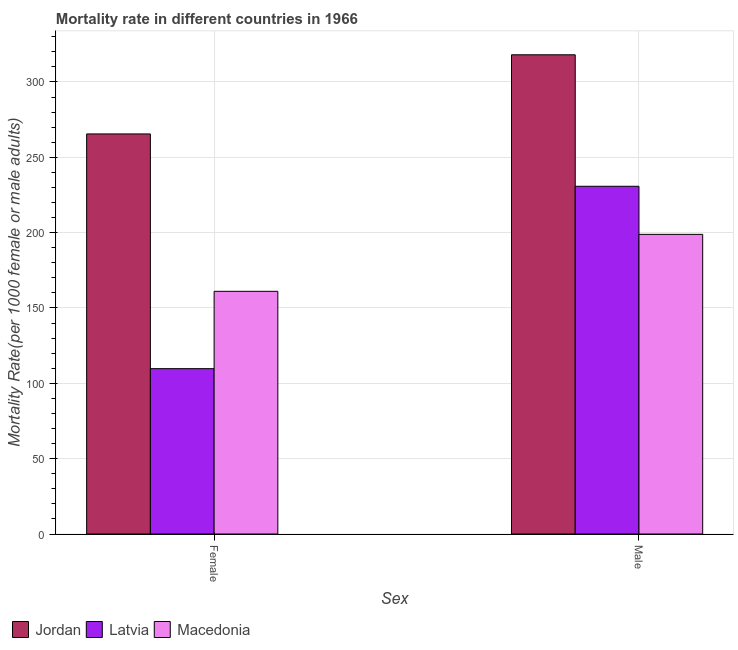Are the number of bars per tick equal to the number of legend labels?
Make the answer very short. Yes. Are the number of bars on each tick of the X-axis equal?
Keep it short and to the point. Yes. What is the label of the 1st group of bars from the left?
Offer a terse response. Female. What is the female mortality rate in Macedonia?
Offer a terse response. 161.06. Across all countries, what is the maximum female mortality rate?
Your answer should be compact. 265.5. Across all countries, what is the minimum female mortality rate?
Offer a very short reply. 109.72. In which country was the male mortality rate maximum?
Your answer should be very brief. Jordan. In which country was the male mortality rate minimum?
Give a very brief answer. Macedonia. What is the total female mortality rate in the graph?
Your response must be concise. 536.29. What is the difference between the male mortality rate in Macedonia and that in Latvia?
Make the answer very short. -31.91. What is the difference between the female mortality rate in Jordan and the male mortality rate in Latvia?
Offer a terse response. 34.74. What is the average male mortality rate per country?
Ensure brevity in your answer.  249.21. What is the difference between the female mortality rate and male mortality rate in Jordan?
Provide a short and direct response. -52.52. What is the ratio of the female mortality rate in Latvia to that in Jordan?
Ensure brevity in your answer.  0.41. What does the 1st bar from the left in Male represents?
Give a very brief answer. Jordan. What does the 2nd bar from the right in Female represents?
Ensure brevity in your answer.  Latvia. Are all the bars in the graph horizontal?
Ensure brevity in your answer.  No. What is the difference between two consecutive major ticks on the Y-axis?
Your response must be concise. 50. Are the values on the major ticks of Y-axis written in scientific E-notation?
Offer a very short reply. No. Where does the legend appear in the graph?
Give a very brief answer. Bottom left. What is the title of the graph?
Give a very brief answer. Mortality rate in different countries in 1966. What is the label or title of the X-axis?
Offer a very short reply. Sex. What is the label or title of the Y-axis?
Offer a very short reply. Mortality Rate(per 1000 female or male adults). What is the Mortality Rate(per 1000 female or male adults) of Jordan in Female?
Provide a succinct answer. 265.5. What is the Mortality Rate(per 1000 female or male adults) in Latvia in Female?
Your answer should be very brief. 109.72. What is the Mortality Rate(per 1000 female or male adults) in Macedonia in Female?
Your answer should be very brief. 161.06. What is the Mortality Rate(per 1000 female or male adults) in Jordan in Male?
Provide a succinct answer. 318.03. What is the Mortality Rate(per 1000 female or male adults) of Latvia in Male?
Give a very brief answer. 230.76. What is the Mortality Rate(per 1000 female or male adults) in Macedonia in Male?
Make the answer very short. 198.85. Across all Sex, what is the maximum Mortality Rate(per 1000 female or male adults) in Jordan?
Make the answer very short. 318.03. Across all Sex, what is the maximum Mortality Rate(per 1000 female or male adults) of Latvia?
Offer a very short reply. 230.76. Across all Sex, what is the maximum Mortality Rate(per 1000 female or male adults) of Macedonia?
Offer a very short reply. 198.85. Across all Sex, what is the minimum Mortality Rate(per 1000 female or male adults) in Jordan?
Keep it short and to the point. 265.5. Across all Sex, what is the minimum Mortality Rate(per 1000 female or male adults) of Latvia?
Offer a terse response. 109.72. Across all Sex, what is the minimum Mortality Rate(per 1000 female or male adults) of Macedonia?
Your answer should be very brief. 161.06. What is the total Mortality Rate(per 1000 female or male adults) of Jordan in the graph?
Your response must be concise. 583.53. What is the total Mortality Rate(per 1000 female or male adults) in Latvia in the graph?
Your answer should be compact. 340.49. What is the total Mortality Rate(per 1000 female or male adults) in Macedonia in the graph?
Offer a terse response. 359.91. What is the difference between the Mortality Rate(per 1000 female or male adults) in Jordan in Female and that in Male?
Give a very brief answer. -52.52. What is the difference between the Mortality Rate(per 1000 female or male adults) of Latvia in Female and that in Male?
Give a very brief answer. -121.04. What is the difference between the Mortality Rate(per 1000 female or male adults) in Macedonia in Female and that in Male?
Make the answer very short. -37.8. What is the difference between the Mortality Rate(per 1000 female or male adults) in Jordan in Female and the Mortality Rate(per 1000 female or male adults) in Latvia in Male?
Your answer should be compact. 34.74. What is the difference between the Mortality Rate(per 1000 female or male adults) of Jordan in Female and the Mortality Rate(per 1000 female or male adults) of Macedonia in Male?
Your response must be concise. 66.65. What is the difference between the Mortality Rate(per 1000 female or male adults) of Latvia in Female and the Mortality Rate(per 1000 female or male adults) of Macedonia in Male?
Ensure brevity in your answer.  -89.13. What is the average Mortality Rate(per 1000 female or male adults) of Jordan per Sex?
Keep it short and to the point. 291.77. What is the average Mortality Rate(per 1000 female or male adults) of Latvia per Sex?
Your answer should be compact. 170.24. What is the average Mortality Rate(per 1000 female or male adults) in Macedonia per Sex?
Provide a short and direct response. 179.96. What is the difference between the Mortality Rate(per 1000 female or male adults) in Jordan and Mortality Rate(per 1000 female or male adults) in Latvia in Female?
Make the answer very short. 155.78. What is the difference between the Mortality Rate(per 1000 female or male adults) in Jordan and Mortality Rate(per 1000 female or male adults) in Macedonia in Female?
Ensure brevity in your answer.  104.45. What is the difference between the Mortality Rate(per 1000 female or male adults) in Latvia and Mortality Rate(per 1000 female or male adults) in Macedonia in Female?
Your answer should be compact. -51.33. What is the difference between the Mortality Rate(per 1000 female or male adults) in Jordan and Mortality Rate(per 1000 female or male adults) in Latvia in Male?
Offer a terse response. 87.26. What is the difference between the Mortality Rate(per 1000 female or male adults) in Jordan and Mortality Rate(per 1000 female or male adults) in Macedonia in Male?
Your response must be concise. 119.17. What is the difference between the Mortality Rate(per 1000 female or male adults) of Latvia and Mortality Rate(per 1000 female or male adults) of Macedonia in Male?
Ensure brevity in your answer.  31.91. What is the ratio of the Mortality Rate(per 1000 female or male adults) in Jordan in Female to that in Male?
Offer a very short reply. 0.83. What is the ratio of the Mortality Rate(per 1000 female or male adults) in Latvia in Female to that in Male?
Offer a terse response. 0.48. What is the ratio of the Mortality Rate(per 1000 female or male adults) in Macedonia in Female to that in Male?
Offer a very short reply. 0.81. What is the difference between the highest and the second highest Mortality Rate(per 1000 female or male adults) of Jordan?
Keep it short and to the point. 52.52. What is the difference between the highest and the second highest Mortality Rate(per 1000 female or male adults) in Latvia?
Keep it short and to the point. 121.04. What is the difference between the highest and the second highest Mortality Rate(per 1000 female or male adults) in Macedonia?
Your response must be concise. 37.8. What is the difference between the highest and the lowest Mortality Rate(per 1000 female or male adults) of Jordan?
Your response must be concise. 52.52. What is the difference between the highest and the lowest Mortality Rate(per 1000 female or male adults) of Latvia?
Your answer should be compact. 121.04. What is the difference between the highest and the lowest Mortality Rate(per 1000 female or male adults) of Macedonia?
Keep it short and to the point. 37.8. 